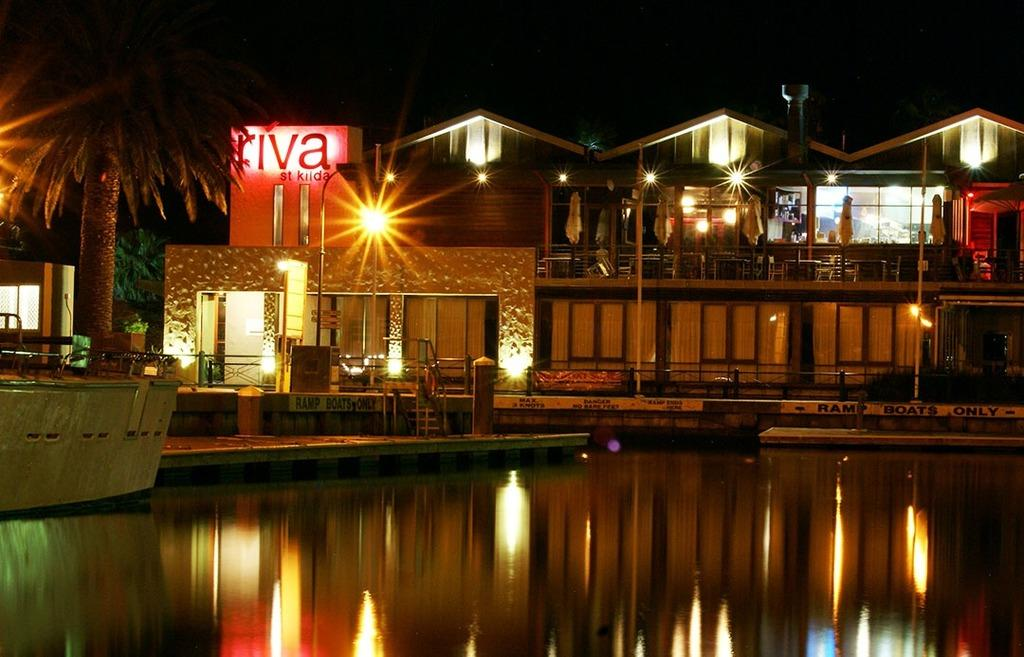What is the primary element in the image? There is water in the image. What can be seen behind the water? There is a path visible behind the water. Are there any structures near the path? Yes, there are poles present near the path. What type of vegetation is visible in the image? There is a tree visible in the image. What can be seen in the background of the image? There is a building with lights and glass in the background of the image. What type of knowledge is being shared by the linen in the image? There is no linen present in the image, so it is not possible to determine what type of knowledge might be shared. 